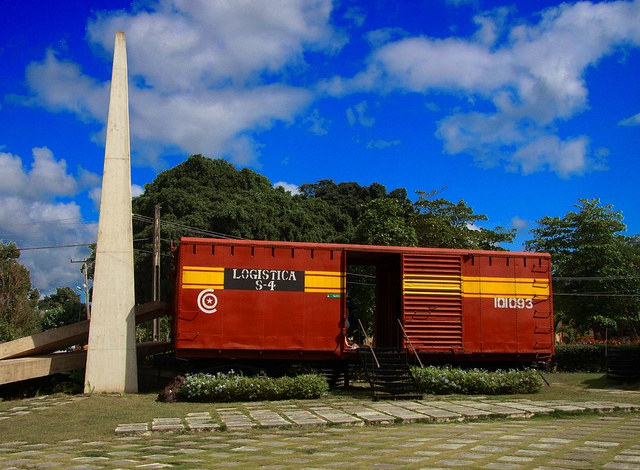Describe the objects in this image and their specific colors. I can see a train in darkblue, maroon, black, and orange tones in this image. 